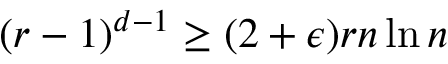<formula> <loc_0><loc_0><loc_500><loc_500>( r - 1 ) ^ { d - 1 } \geq ( 2 + \epsilon ) r n \ln n</formula> 